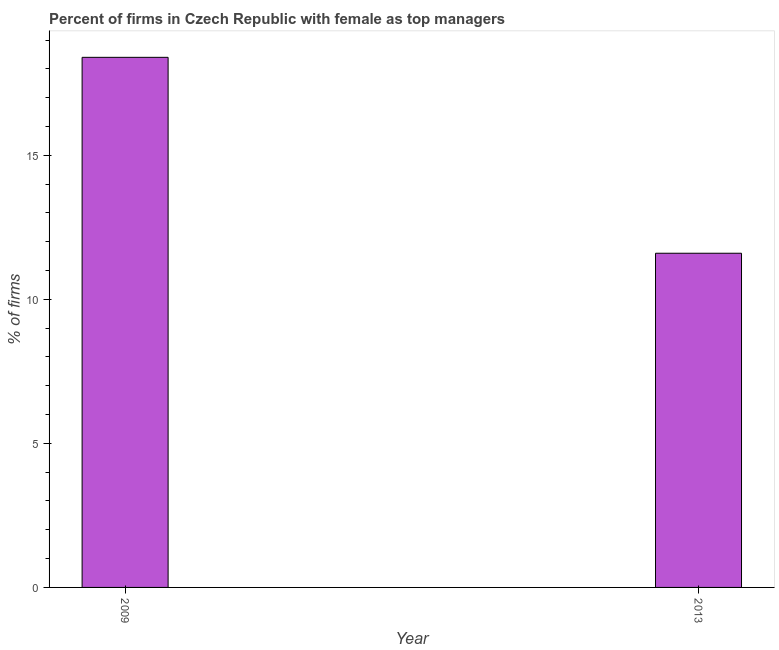Does the graph contain any zero values?
Your answer should be very brief. No. What is the title of the graph?
Offer a very short reply. Percent of firms in Czech Republic with female as top managers. What is the label or title of the Y-axis?
Offer a very short reply. % of firms. What is the percentage of firms with female as top manager in 2013?
Give a very brief answer. 11.6. Across all years, what is the maximum percentage of firms with female as top manager?
Your response must be concise. 18.4. In which year was the percentage of firms with female as top manager maximum?
Provide a succinct answer. 2009. What is the difference between the percentage of firms with female as top manager in 2009 and 2013?
Your response must be concise. 6.8. What is the ratio of the percentage of firms with female as top manager in 2009 to that in 2013?
Your answer should be very brief. 1.59. Is the percentage of firms with female as top manager in 2009 less than that in 2013?
Provide a succinct answer. No. How many years are there in the graph?
Your answer should be very brief. 2. What is the difference between two consecutive major ticks on the Y-axis?
Ensure brevity in your answer.  5. Are the values on the major ticks of Y-axis written in scientific E-notation?
Your answer should be compact. No. What is the % of firms in 2009?
Your answer should be very brief. 18.4. What is the difference between the % of firms in 2009 and 2013?
Your answer should be compact. 6.8. What is the ratio of the % of firms in 2009 to that in 2013?
Make the answer very short. 1.59. 